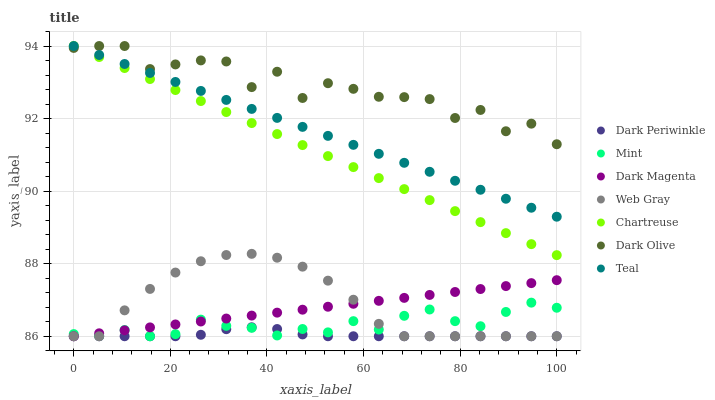Does Dark Periwinkle have the minimum area under the curve?
Answer yes or no. Yes. Does Dark Olive have the maximum area under the curve?
Answer yes or no. Yes. Does Dark Magenta have the minimum area under the curve?
Answer yes or no. No. Does Dark Magenta have the maximum area under the curve?
Answer yes or no. No. Is Dark Magenta the smoothest?
Answer yes or no. Yes. Is Dark Olive the roughest?
Answer yes or no. Yes. Is Dark Olive the smoothest?
Answer yes or no. No. Is Dark Magenta the roughest?
Answer yes or no. No. Does Web Gray have the lowest value?
Answer yes or no. Yes. Does Dark Olive have the lowest value?
Answer yes or no. No. Does Teal have the highest value?
Answer yes or no. Yes. Does Dark Magenta have the highest value?
Answer yes or no. No. Is Dark Magenta less than Chartreuse?
Answer yes or no. Yes. Is Teal greater than Dark Periwinkle?
Answer yes or no. Yes. Does Chartreuse intersect Teal?
Answer yes or no. Yes. Is Chartreuse less than Teal?
Answer yes or no. No. Is Chartreuse greater than Teal?
Answer yes or no. No. Does Dark Magenta intersect Chartreuse?
Answer yes or no. No. 